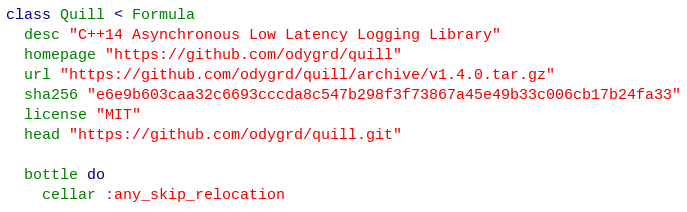<code> <loc_0><loc_0><loc_500><loc_500><_Ruby_>class Quill < Formula
  desc "C++14 Asynchronous Low Latency Logging Library"
  homepage "https://github.com/odygrd/quill"
  url "https://github.com/odygrd/quill/archive/v1.4.0.tar.gz"
  sha256 "e6e9b603caa32c6693cccda8c547b298f3f73867a45e49b33c006cb17b24fa33"
  license "MIT"
  head "https://github.com/odygrd/quill.git"

  bottle do
    cellar :any_skip_relocation</code> 